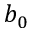Convert formula to latex. <formula><loc_0><loc_0><loc_500><loc_500>b _ { 0 }</formula> 